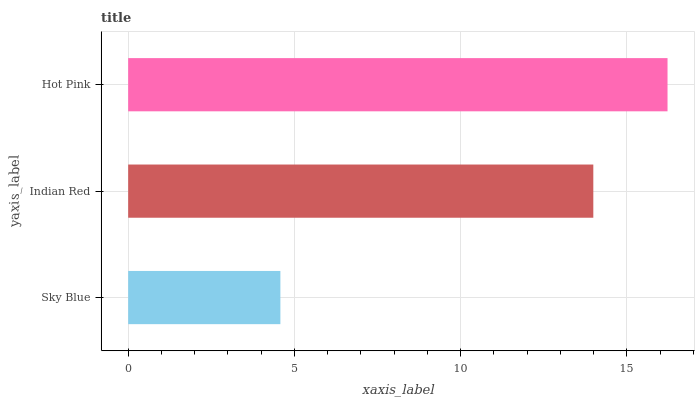Is Sky Blue the minimum?
Answer yes or no. Yes. Is Hot Pink the maximum?
Answer yes or no. Yes. Is Indian Red the minimum?
Answer yes or no. No. Is Indian Red the maximum?
Answer yes or no. No. Is Indian Red greater than Sky Blue?
Answer yes or no. Yes. Is Sky Blue less than Indian Red?
Answer yes or no. Yes. Is Sky Blue greater than Indian Red?
Answer yes or no. No. Is Indian Red less than Sky Blue?
Answer yes or no. No. Is Indian Red the high median?
Answer yes or no. Yes. Is Indian Red the low median?
Answer yes or no. Yes. Is Sky Blue the high median?
Answer yes or no. No. Is Sky Blue the low median?
Answer yes or no. No. 